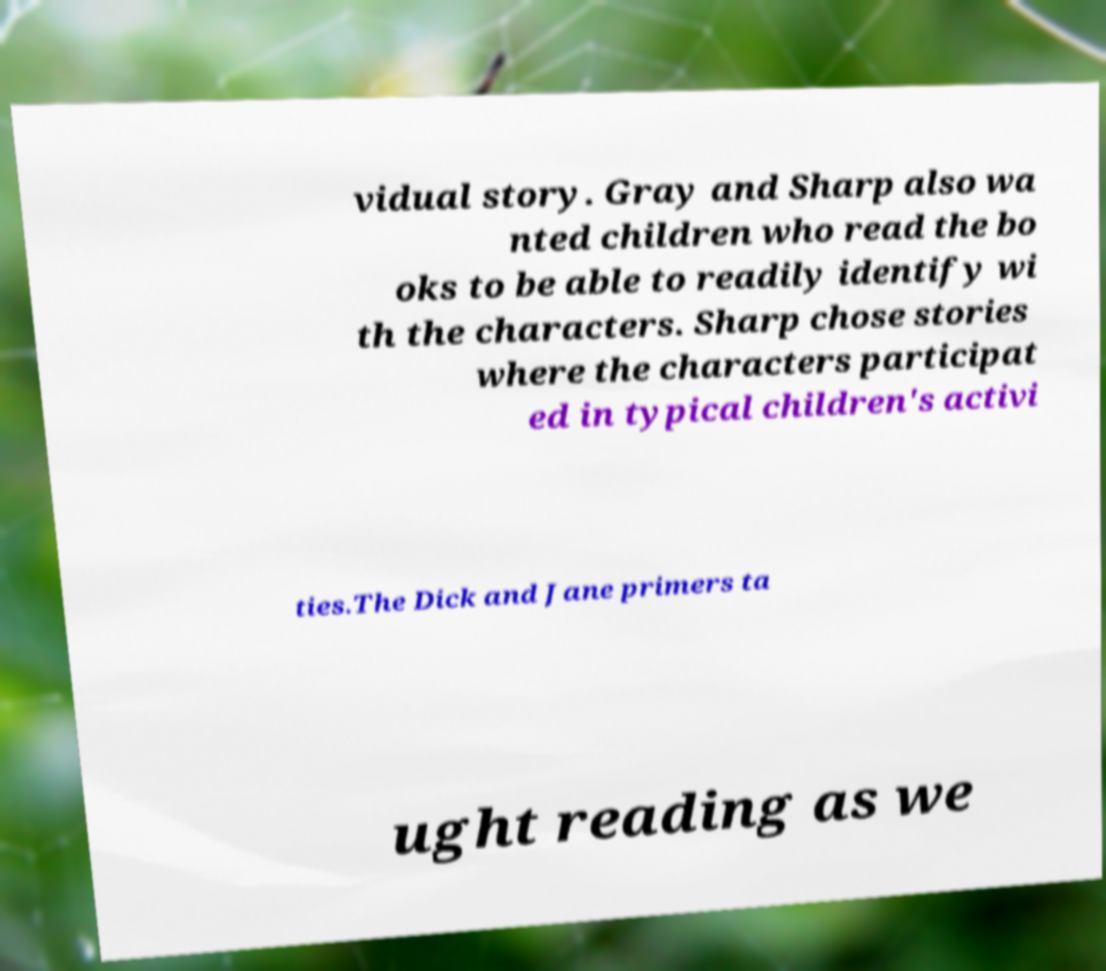Can you read and provide the text displayed in the image?This photo seems to have some interesting text. Can you extract and type it out for me? vidual story. Gray and Sharp also wa nted children who read the bo oks to be able to readily identify wi th the characters. Sharp chose stories where the characters participat ed in typical children's activi ties.The Dick and Jane primers ta ught reading as we 